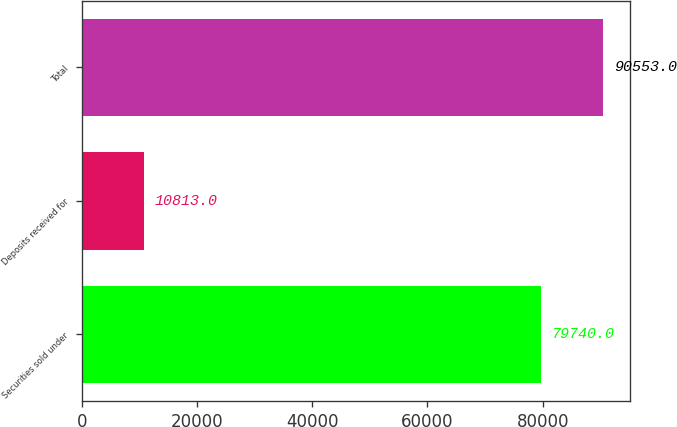Convert chart. <chart><loc_0><loc_0><loc_500><loc_500><bar_chart><fcel>Securities sold under<fcel>Deposits received for<fcel>Total<nl><fcel>79740<fcel>10813<fcel>90553<nl></chart> 